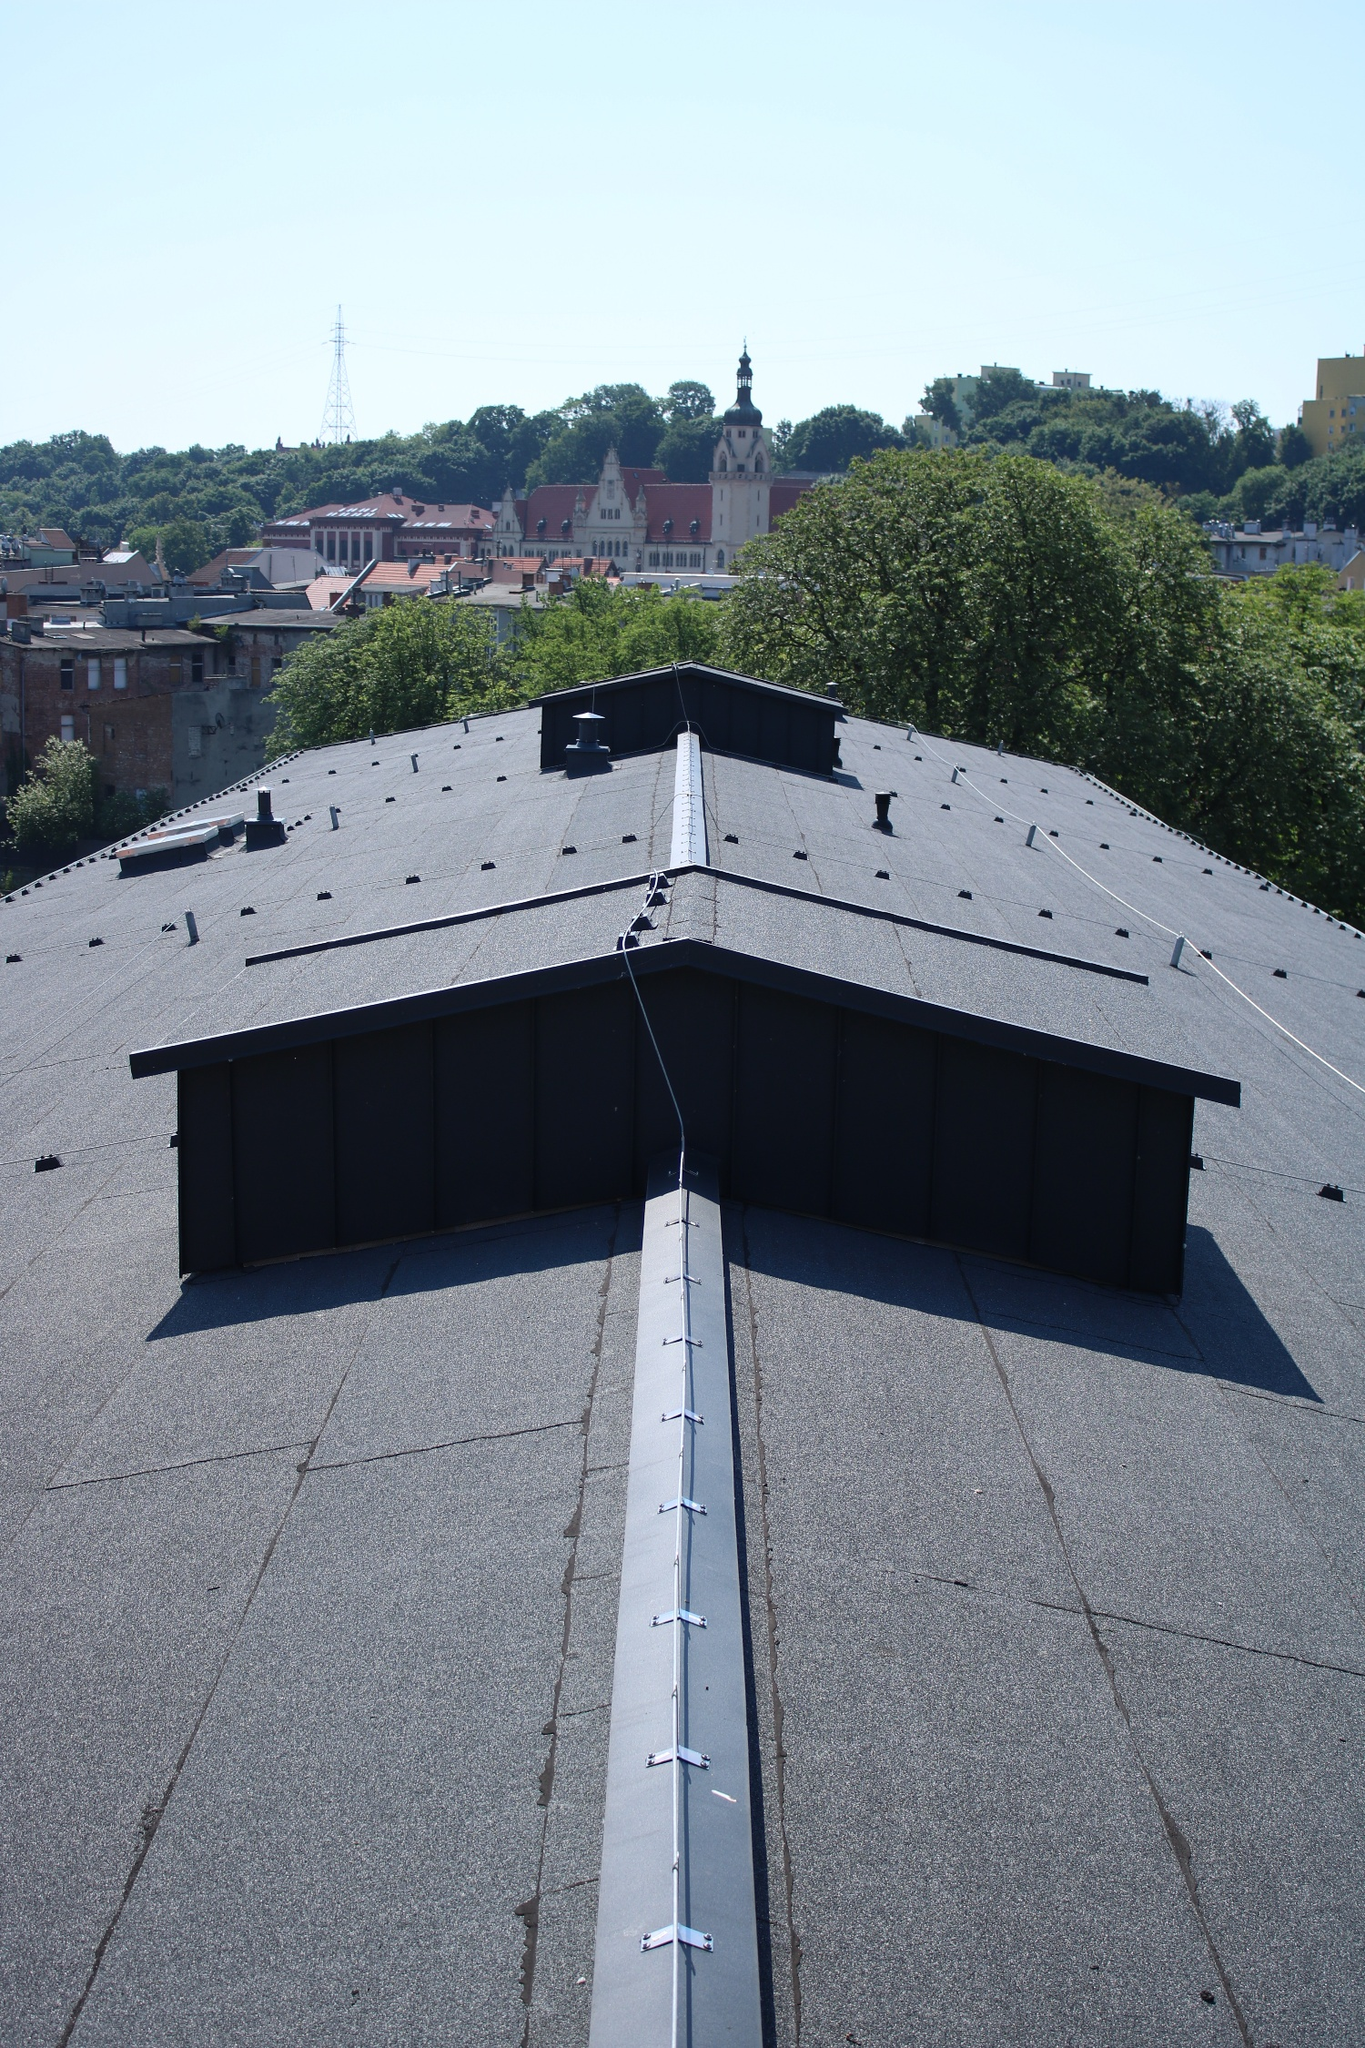What can you infer about the architectural styles present in this cityscape? The cityscape features a diverse array of architectural styles. In the foreground, the prominent rooftop has a modern, industrial appearance with clean lines and functional elements such as chimneys and vents. Moving further into the background, the buildings exhibit more traditional architectural styles. The prominent church-like structure with its spire suggests elements of Gothic or Baroque influences, characterized by the ornate detailing and majestic presence. Surrounding buildings display a mix of historical and contemporary designs, indicating a city with a rich architectural heritage that has evolved through various periods. What might be the history or significance of the church-like structure visible in the background? The church-like structure with its distinct spire likely holds historical and cultural significance. Structures of this nature often serve as religious centers and community landmarks, indicating that this building might be a historic church or cathedral. The architectural features, such as the tall spire and intricate facade, suggest it was built during a period emphasizing grandeur and elaborate design, potentially during the Gothic or Baroque periods. This building may have been a focal point in religious, social, and cultural activities, serving as a testament to the city's heritage and the craftsmanship of the era. It could also be a symbol of the city's spiritual and historical journey, reflecting the community's values and traditions across centuries. 